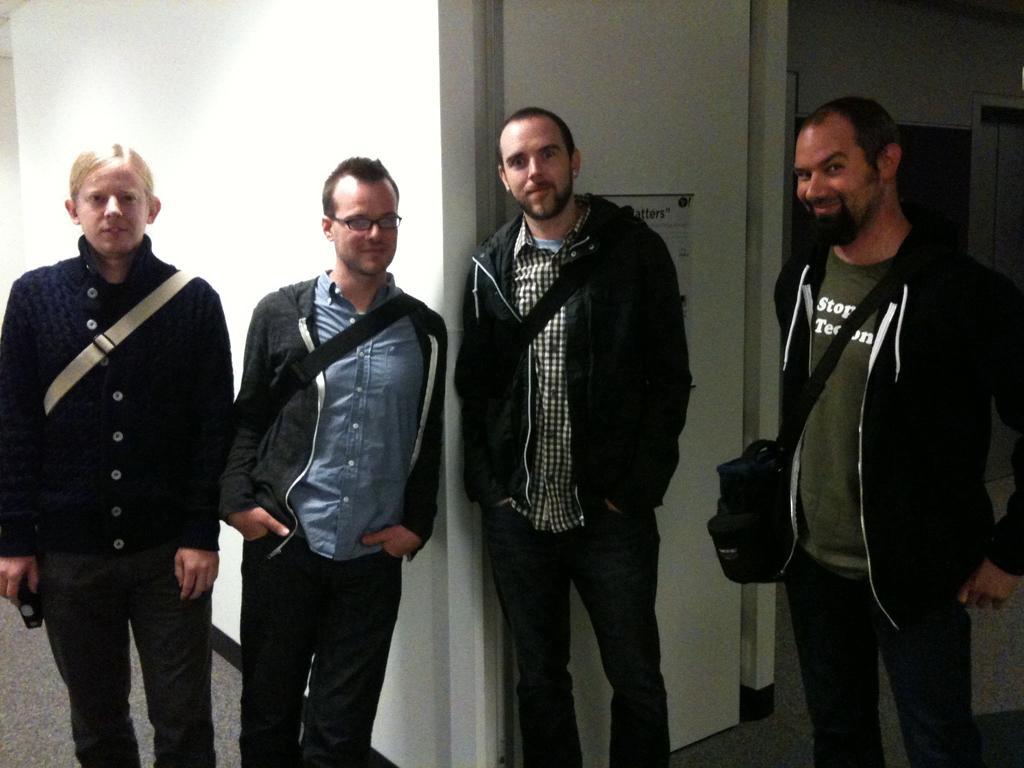Can you describe this image briefly? In this picture four persons are standing and giving some still. Four persons wore black jacket and black trouser, back side of them there is a white wall. This man wore spectacles and kept his hands in his pockets. 